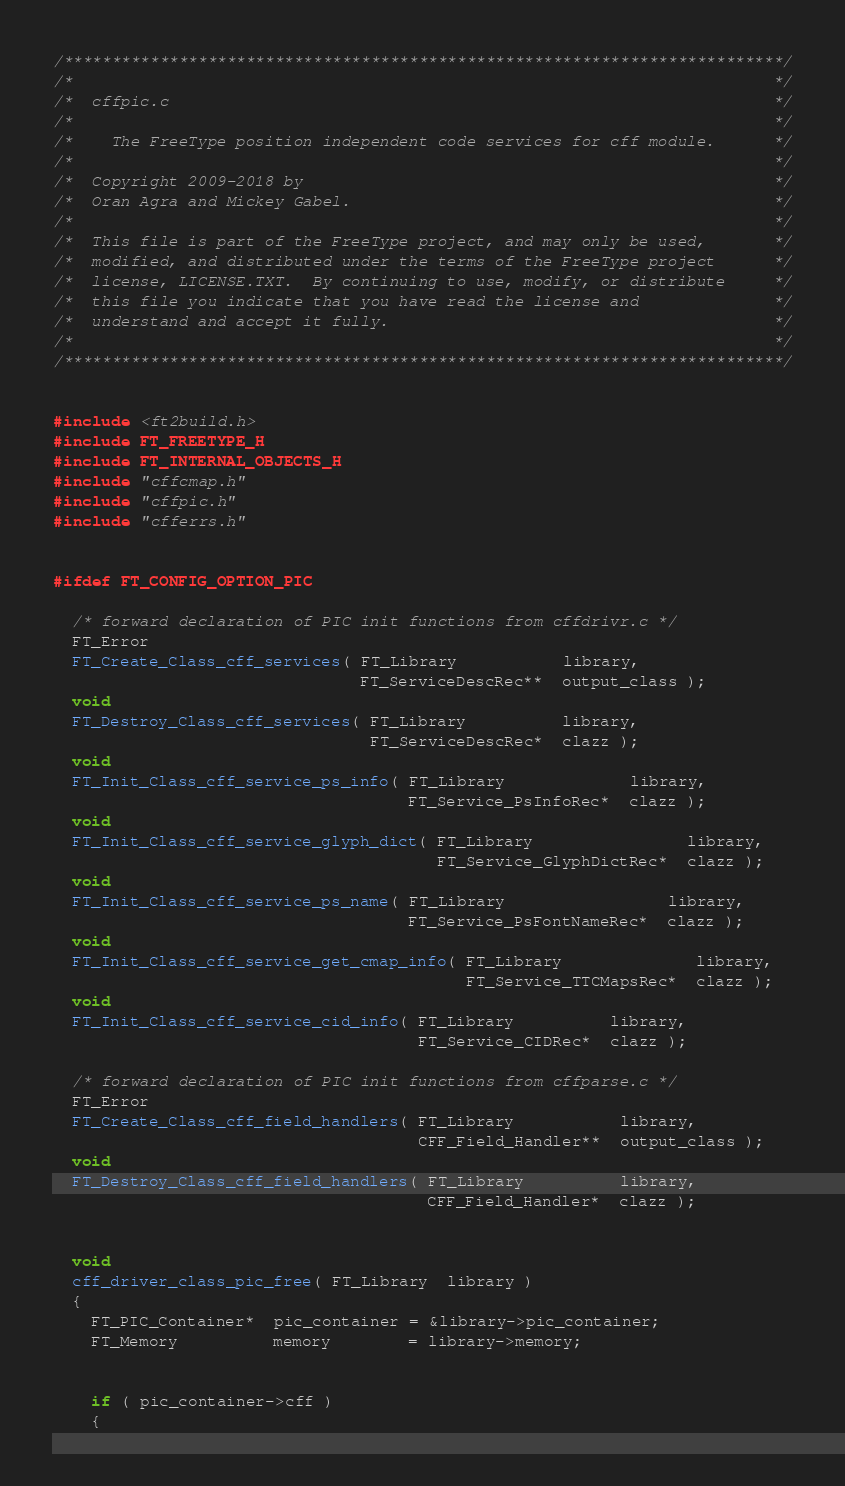Convert code to text. <code><loc_0><loc_0><loc_500><loc_500><_C_>/***************************************************************************/
/*                                                                         */
/*  cffpic.c                                                               */
/*                                                                         */
/*    The FreeType position independent code services for cff module.      */
/*                                                                         */
/*  Copyright 2009-2018 by                                                 */
/*  Oran Agra and Mickey Gabel.                                            */
/*                                                                         */
/*  This file is part of the FreeType project, and may only be used,       */
/*  modified, and distributed under the terms of the FreeType project      */
/*  license, LICENSE.TXT.  By continuing to use, modify, or distribute     */
/*  this file you indicate that you have read the license and              */
/*  understand and accept it fully.                                        */
/*                                                                         */
/***************************************************************************/


#include <ft2build.h>
#include FT_FREETYPE_H
#include FT_INTERNAL_OBJECTS_H
#include "cffcmap.h"
#include "cffpic.h"
#include "cfferrs.h"


#ifdef FT_CONFIG_OPTION_PIC

  /* forward declaration of PIC init functions from cffdrivr.c */
  FT_Error
  FT_Create_Class_cff_services( FT_Library           library,
                                FT_ServiceDescRec**  output_class );
  void
  FT_Destroy_Class_cff_services( FT_Library          library,
                                 FT_ServiceDescRec*  clazz );
  void
  FT_Init_Class_cff_service_ps_info( FT_Library             library,
                                     FT_Service_PsInfoRec*  clazz );
  void
  FT_Init_Class_cff_service_glyph_dict( FT_Library                library,
                                        FT_Service_GlyphDictRec*  clazz );
  void
  FT_Init_Class_cff_service_ps_name( FT_Library                 library,
                                     FT_Service_PsFontNameRec*  clazz );
  void
  FT_Init_Class_cff_service_get_cmap_info( FT_Library              library,
                                           FT_Service_TTCMapsRec*  clazz );
  void
  FT_Init_Class_cff_service_cid_info( FT_Library          library,
                                      FT_Service_CIDRec*  clazz );

  /* forward declaration of PIC init functions from cffparse.c */
  FT_Error
  FT_Create_Class_cff_field_handlers( FT_Library           library,
                                      CFF_Field_Handler**  output_class );
  void
  FT_Destroy_Class_cff_field_handlers( FT_Library          library,
                                       CFF_Field_Handler*  clazz );


  void
  cff_driver_class_pic_free( FT_Library  library )
  {
    FT_PIC_Container*  pic_container = &library->pic_container;
    FT_Memory          memory        = library->memory;


    if ( pic_container->cff )
    {</code> 